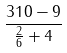<formula> <loc_0><loc_0><loc_500><loc_500>\frac { 3 1 0 - 9 } { \frac { 2 } { 6 } + 4 }</formula> 